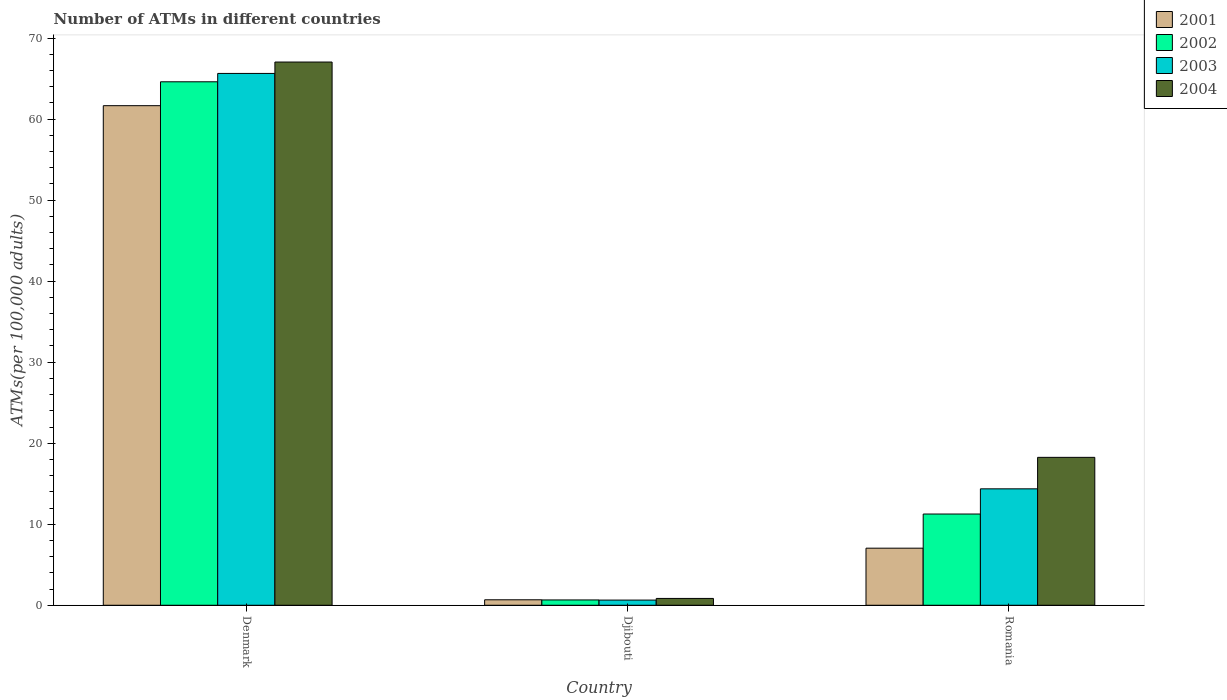How many groups of bars are there?
Offer a terse response. 3. How many bars are there on the 1st tick from the right?
Offer a terse response. 4. In how many cases, is the number of bars for a given country not equal to the number of legend labels?
Your response must be concise. 0. What is the number of ATMs in 2001 in Denmark?
Give a very brief answer. 61.66. Across all countries, what is the maximum number of ATMs in 2003?
Your answer should be very brief. 65.64. Across all countries, what is the minimum number of ATMs in 2004?
Ensure brevity in your answer.  0.84. In which country was the number of ATMs in 2001 minimum?
Make the answer very short. Djibouti. What is the total number of ATMs in 2004 in the graph?
Your answer should be compact. 86.14. What is the difference between the number of ATMs in 2001 in Denmark and that in Djibouti?
Offer a terse response. 60.98. What is the difference between the number of ATMs in 2003 in Romania and the number of ATMs in 2004 in Djibouti?
Offer a very short reply. 13.53. What is the average number of ATMs in 2001 per country?
Keep it short and to the point. 23.13. What is the difference between the number of ATMs of/in 2003 and number of ATMs of/in 2004 in Denmark?
Provide a short and direct response. -1.41. In how many countries, is the number of ATMs in 2003 greater than 66?
Ensure brevity in your answer.  0. What is the ratio of the number of ATMs in 2002 in Denmark to that in Romania?
Make the answer very short. 5.74. Is the number of ATMs in 2003 in Djibouti less than that in Romania?
Your answer should be compact. Yes. What is the difference between the highest and the second highest number of ATMs in 2002?
Offer a terse response. 63.95. What is the difference between the highest and the lowest number of ATMs in 2003?
Offer a very short reply. 65. What does the 2nd bar from the left in Djibouti represents?
Provide a short and direct response. 2002. Is it the case that in every country, the sum of the number of ATMs in 2004 and number of ATMs in 2001 is greater than the number of ATMs in 2003?
Your answer should be very brief. Yes. Are all the bars in the graph horizontal?
Keep it short and to the point. No. How many countries are there in the graph?
Ensure brevity in your answer.  3. What is the difference between two consecutive major ticks on the Y-axis?
Your answer should be compact. 10. Are the values on the major ticks of Y-axis written in scientific E-notation?
Your answer should be compact. No. Does the graph contain any zero values?
Your answer should be very brief. No. How many legend labels are there?
Your answer should be very brief. 4. What is the title of the graph?
Make the answer very short. Number of ATMs in different countries. What is the label or title of the Y-axis?
Your answer should be compact. ATMs(per 100,0 adults). What is the ATMs(per 100,000 adults) in 2001 in Denmark?
Make the answer very short. 61.66. What is the ATMs(per 100,000 adults) in 2002 in Denmark?
Keep it short and to the point. 64.61. What is the ATMs(per 100,000 adults) in 2003 in Denmark?
Keep it short and to the point. 65.64. What is the ATMs(per 100,000 adults) in 2004 in Denmark?
Your answer should be compact. 67.04. What is the ATMs(per 100,000 adults) of 2001 in Djibouti?
Offer a very short reply. 0.68. What is the ATMs(per 100,000 adults) of 2002 in Djibouti?
Give a very brief answer. 0.66. What is the ATMs(per 100,000 adults) in 2003 in Djibouti?
Give a very brief answer. 0.64. What is the ATMs(per 100,000 adults) in 2004 in Djibouti?
Your answer should be very brief. 0.84. What is the ATMs(per 100,000 adults) of 2001 in Romania?
Your answer should be compact. 7.04. What is the ATMs(per 100,000 adults) in 2002 in Romania?
Offer a very short reply. 11.26. What is the ATMs(per 100,000 adults) in 2003 in Romania?
Keep it short and to the point. 14.37. What is the ATMs(per 100,000 adults) in 2004 in Romania?
Your answer should be very brief. 18.26. Across all countries, what is the maximum ATMs(per 100,000 adults) in 2001?
Provide a succinct answer. 61.66. Across all countries, what is the maximum ATMs(per 100,000 adults) of 2002?
Offer a very short reply. 64.61. Across all countries, what is the maximum ATMs(per 100,000 adults) in 2003?
Offer a terse response. 65.64. Across all countries, what is the maximum ATMs(per 100,000 adults) in 2004?
Keep it short and to the point. 67.04. Across all countries, what is the minimum ATMs(per 100,000 adults) of 2001?
Give a very brief answer. 0.68. Across all countries, what is the minimum ATMs(per 100,000 adults) in 2002?
Your answer should be very brief. 0.66. Across all countries, what is the minimum ATMs(per 100,000 adults) of 2003?
Provide a succinct answer. 0.64. Across all countries, what is the minimum ATMs(per 100,000 adults) of 2004?
Provide a succinct answer. 0.84. What is the total ATMs(per 100,000 adults) in 2001 in the graph?
Your answer should be very brief. 69.38. What is the total ATMs(per 100,000 adults) of 2002 in the graph?
Ensure brevity in your answer.  76.52. What is the total ATMs(per 100,000 adults) of 2003 in the graph?
Make the answer very short. 80.65. What is the total ATMs(per 100,000 adults) in 2004 in the graph?
Ensure brevity in your answer.  86.14. What is the difference between the ATMs(per 100,000 adults) in 2001 in Denmark and that in Djibouti?
Ensure brevity in your answer.  60.98. What is the difference between the ATMs(per 100,000 adults) in 2002 in Denmark and that in Djibouti?
Give a very brief answer. 63.95. What is the difference between the ATMs(per 100,000 adults) in 2003 in Denmark and that in Djibouti?
Provide a succinct answer. 65. What is the difference between the ATMs(per 100,000 adults) in 2004 in Denmark and that in Djibouti?
Offer a very short reply. 66.2. What is the difference between the ATMs(per 100,000 adults) in 2001 in Denmark and that in Romania?
Provide a succinct answer. 54.61. What is the difference between the ATMs(per 100,000 adults) of 2002 in Denmark and that in Romania?
Offer a terse response. 53.35. What is the difference between the ATMs(per 100,000 adults) of 2003 in Denmark and that in Romania?
Provide a succinct answer. 51.27. What is the difference between the ATMs(per 100,000 adults) in 2004 in Denmark and that in Romania?
Offer a terse response. 48.79. What is the difference between the ATMs(per 100,000 adults) of 2001 in Djibouti and that in Romania?
Keep it short and to the point. -6.37. What is the difference between the ATMs(per 100,000 adults) of 2002 in Djibouti and that in Romania?
Provide a succinct answer. -10.6. What is the difference between the ATMs(per 100,000 adults) in 2003 in Djibouti and that in Romania?
Make the answer very short. -13.73. What is the difference between the ATMs(per 100,000 adults) in 2004 in Djibouti and that in Romania?
Give a very brief answer. -17.41. What is the difference between the ATMs(per 100,000 adults) of 2001 in Denmark and the ATMs(per 100,000 adults) of 2002 in Djibouti?
Your answer should be compact. 61. What is the difference between the ATMs(per 100,000 adults) of 2001 in Denmark and the ATMs(per 100,000 adults) of 2003 in Djibouti?
Make the answer very short. 61.02. What is the difference between the ATMs(per 100,000 adults) of 2001 in Denmark and the ATMs(per 100,000 adults) of 2004 in Djibouti?
Provide a succinct answer. 60.81. What is the difference between the ATMs(per 100,000 adults) in 2002 in Denmark and the ATMs(per 100,000 adults) in 2003 in Djibouti?
Your response must be concise. 63.97. What is the difference between the ATMs(per 100,000 adults) in 2002 in Denmark and the ATMs(per 100,000 adults) in 2004 in Djibouti?
Provide a short and direct response. 63.76. What is the difference between the ATMs(per 100,000 adults) in 2003 in Denmark and the ATMs(per 100,000 adults) in 2004 in Djibouti?
Provide a short and direct response. 64.79. What is the difference between the ATMs(per 100,000 adults) of 2001 in Denmark and the ATMs(per 100,000 adults) of 2002 in Romania?
Ensure brevity in your answer.  50.4. What is the difference between the ATMs(per 100,000 adults) in 2001 in Denmark and the ATMs(per 100,000 adults) in 2003 in Romania?
Provide a succinct answer. 47.29. What is the difference between the ATMs(per 100,000 adults) of 2001 in Denmark and the ATMs(per 100,000 adults) of 2004 in Romania?
Make the answer very short. 43.4. What is the difference between the ATMs(per 100,000 adults) in 2002 in Denmark and the ATMs(per 100,000 adults) in 2003 in Romania?
Your response must be concise. 50.24. What is the difference between the ATMs(per 100,000 adults) of 2002 in Denmark and the ATMs(per 100,000 adults) of 2004 in Romania?
Keep it short and to the point. 46.35. What is the difference between the ATMs(per 100,000 adults) of 2003 in Denmark and the ATMs(per 100,000 adults) of 2004 in Romania?
Offer a terse response. 47.38. What is the difference between the ATMs(per 100,000 adults) of 2001 in Djibouti and the ATMs(per 100,000 adults) of 2002 in Romania?
Your response must be concise. -10.58. What is the difference between the ATMs(per 100,000 adults) of 2001 in Djibouti and the ATMs(per 100,000 adults) of 2003 in Romania?
Keep it short and to the point. -13.69. What is the difference between the ATMs(per 100,000 adults) in 2001 in Djibouti and the ATMs(per 100,000 adults) in 2004 in Romania?
Offer a very short reply. -17.58. What is the difference between the ATMs(per 100,000 adults) in 2002 in Djibouti and the ATMs(per 100,000 adults) in 2003 in Romania?
Make the answer very short. -13.71. What is the difference between the ATMs(per 100,000 adults) of 2002 in Djibouti and the ATMs(per 100,000 adults) of 2004 in Romania?
Keep it short and to the point. -17.6. What is the difference between the ATMs(per 100,000 adults) in 2003 in Djibouti and the ATMs(per 100,000 adults) in 2004 in Romania?
Provide a short and direct response. -17.62. What is the average ATMs(per 100,000 adults) of 2001 per country?
Keep it short and to the point. 23.13. What is the average ATMs(per 100,000 adults) of 2002 per country?
Give a very brief answer. 25.51. What is the average ATMs(per 100,000 adults) of 2003 per country?
Keep it short and to the point. 26.88. What is the average ATMs(per 100,000 adults) in 2004 per country?
Give a very brief answer. 28.71. What is the difference between the ATMs(per 100,000 adults) in 2001 and ATMs(per 100,000 adults) in 2002 in Denmark?
Ensure brevity in your answer.  -2.95. What is the difference between the ATMs(per 100,000 adults) in 2001 and ATMs(per 100,000 adults) in 2003 in Denmark?
Your answer should be very brief. -3.98. What is the difference between the ATMs(per 100,000 adults) of 2001 and ATMs(per 100,000 adults) of 2004 in Denmark?
Provide a succinct answer. -5.39. What is the difference between the ATMs(per 100,000 adults) of 2002 and ATMs(per 100,000 adults) of 2003 in Denmark?
Your answer should be compact. -1.03. What is the difference between the ATMs(per 100,000 adults) of 2002 and ATMs(per 100,000 adults) of 2004 in Denmark?
Provide a short and direct response. -2.44. What is the difference between the ATMs(per 100,000 adults) in 2003 and ATMs(per 100,000 adults) in 2004 in Denmark?
Keep it short and to the point. -1.41. What is the difference between the ATMs(per 100,000 adults) in 2001 and ATMs(per 100,000 adults) in 2002 in Djibouti?
Your answer should be compact. 0.02. What is the difference between the ATMs(per 100,000 adults) in 2001 and ATMs(per 100,000 adults) in 2003 in Djibouti?
Give a very brief answer. 0.04. What is the difference between the ATMs(per 100,000 adults) of 2001 and ATMs(per 100,000 adults) of 2004 in Djibouti?
Your response must be concise. -0.17. What is the difference between the ATMs(per 100,000 adults) of 2002 and ATMs(per 100,000 adults) of 2003 in Djibouti?
Offer a very short reply. 0.02. What is the difference between the ATMs(per 100,000 adults) in 2002 and ATMs(per 100,000 adults) in 2004 in Djibouti?
Offer a terse response. -0.19. What is the difference between the ATMs(per 100,000 adults) of 2003 and ATMs(per 100,000 adults) of 2004 in Djibouti?
Make the answer very short. -0.21. What is the difference between the ATMs(per 100,000 adults) of 2001 and ATMs(per 100,000 adults) of 2002 in Romania?
Offer a terse response. -4.21. What is the difference between the ATMs(per 100,000 adults) in 2001 and ATMs(per 100,000 adults) in 2003 in Romania?
Your answer should be very brief. -7.32. What is the difference between the ATMs(per 100,000 adults) in 2001 and ATMs(per 100,000 adults) in 2004 in Romania?
Provide a short and direct response. -11.21. What is the difference between the ATMs(per 100,000 adults) of 2002 and ATMs(per 100,000 adults) of 2003 in Romania?
Offer a very short reply. -3.11. What is the difference between the ATMs(per 100,000 adults) of 2002 and ATMs(per 100,000 adults) of 2004 in Romania?
Provide a short and direct response. -7. What is the difference between the ATMs(per 100,000 adults) of 2003 and ATMs(per 100,000 adults) of 2004 in Romania?
Keep it short and to the point. -3.89. What is the ratio of the ATMs(per 100,000 adults) in 2001 in Denmark to that in Djibouti?
Provide a succinct answer. 91.18. What is the ratio of the ATMs(per 100,000 adults) in 2002 in Denmark to that in Djibouti?
Ensure brevity in your answer.  98.45. What is the ratio of the ATMs(per 100,000 adults) of 2003 in Denmark to that in Djibouti?
Give a very brief answer. 102.88. What is the ratio of the ATMs(per 100,000 adults) in 2004 in Denmark to that in Djibouti?
Offer a terse response. 79.46. What is the ratio of the ATMs(per 100,000 adults) in 2001 in Denmark to that in Romania?
Offer a very short reply. 8.75. What is the ratio of the ATMs(per 100,000 adults) of 2002 in Denmark to that in Romania?
Your response must be concise. 5.74. What is the ratio of the ATMs(per 100,000 adults) of 2003 in Denmark to that in Romania?
Your answer should be compact. 4.57. What is the ratio of the ATMs(per 100,000 adults) in 2004 in Denmark to that in Romania?
Offer a very short reply. 3.67. What is the ratio of the ATMs(per 100,000 adults) of 2001 in Djibouti to that in Romania?
Provide a succinct answer. 0.1. What is the ratio of the ATMs(per 100,000 adults) of 2002 in Djibouti to that in Romania?
Your response must be concise. 0.06. What is the ratio of the ATMs(per 100,000 adults) of 2003 in Djibouti to that in Romania?
Ensure brevity in your answer.  0.04. What is the ratio of the ATMs(per 100,000 adults) of 2004 in Djibouti to that in Romania?
Offer a very short reply. 0.05. What is the difference between the highest and the second highest ATMs(per 100,000 adults) in 2001?
Give a very brief answer. 54.61. What is the difference between the highest and the second highest ATMs(per 100,000 adults) of 2002?
Keep it short and to the point. 53.35. What is the difference between the highest and the second highest ATMs(per 100,000 adults) of 2003?
Provide a succinct answer. 51.27. What is the difference between the highest and the second highest ATMs(per 100,000 adults) of 2004?
Provide a short and direct response. 48.79. What is the difference between the highest and the lowest ATMs(per 100,000 adults) of 2001?
Give a very brief answer. 60.98. What is the difference between the highest and the lowest ATMs(per 100,000 adults) of 2002?
Offer a terse response. 63.95. What is the difference between the highest and the lowest ATMs(per 100,000 adults) of 2003?
Offer a terse response. 65. What is the difference between the highest and the lowest ATMs(per 100,000 adults) of 2004?
Provide a short and direct response. 66.2. 